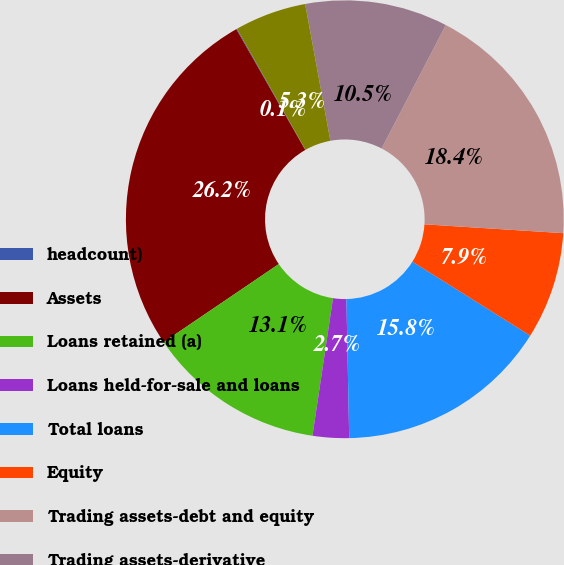Convert chart to OTSL. <chart><loc_0><loc_0><loc_500><loc_500><pie_chart><fcel>headcount)<fcel>Assets<fcel>Loans retained (a)<fcel>Loans held-for-sale and loans<fcel>Total loans<fcel>Equity<fcel>Trading assets-debt and equity<fcel>Trading assets-derivative<fcel>Headcount<nl><fcel>0.06%<fcel>26.23%<fcel>13.15%<fcel>2.68%<fcel>15.76%<fcel>7.91%<fcel>18.38%<fcel>10.53%<fcel>5.3%<nl></chart> 